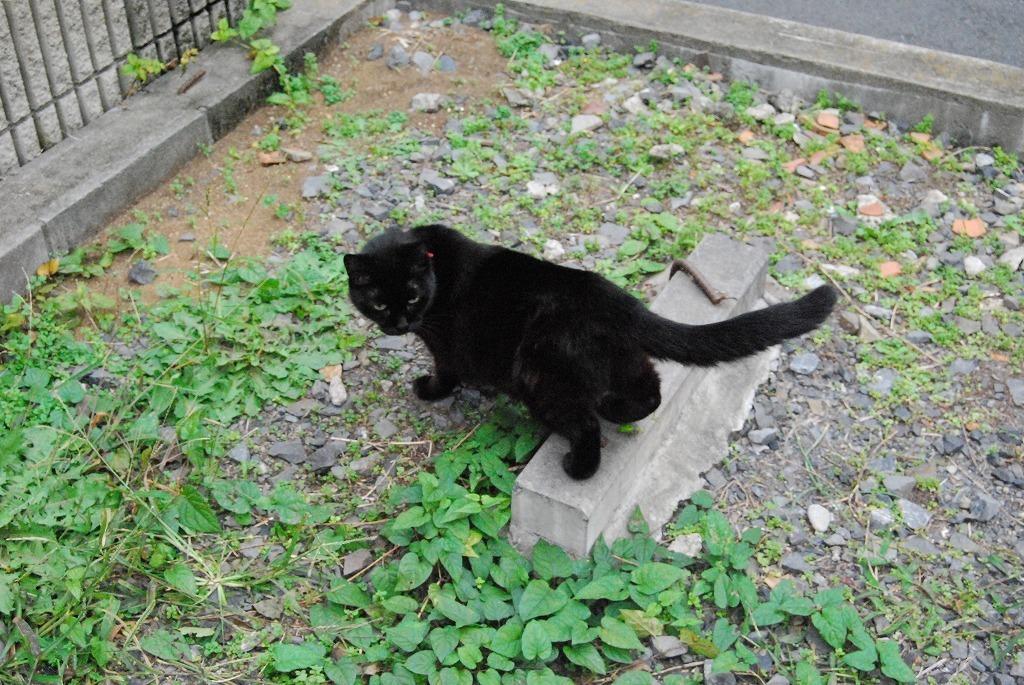Could you give a brief overview of what you see in this image? In this image, we can see some plants. There is a cat in the middle of the image which is colored black. There are grills in the top left of the image. 